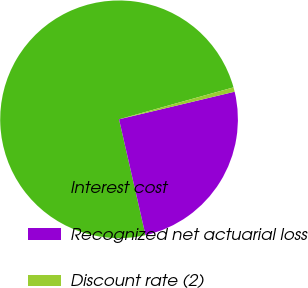Convert chart to OTSL. <chart><loc_0><loc_0><loc_500><loc_500><pie_chart><fcel>Interest cost<fcel>Recognized net actuarial loss<fcel>Discount rate (2)<nl><fcel>74.24%<fcel>25.15%<fcel>0.6%<nl></chart> 